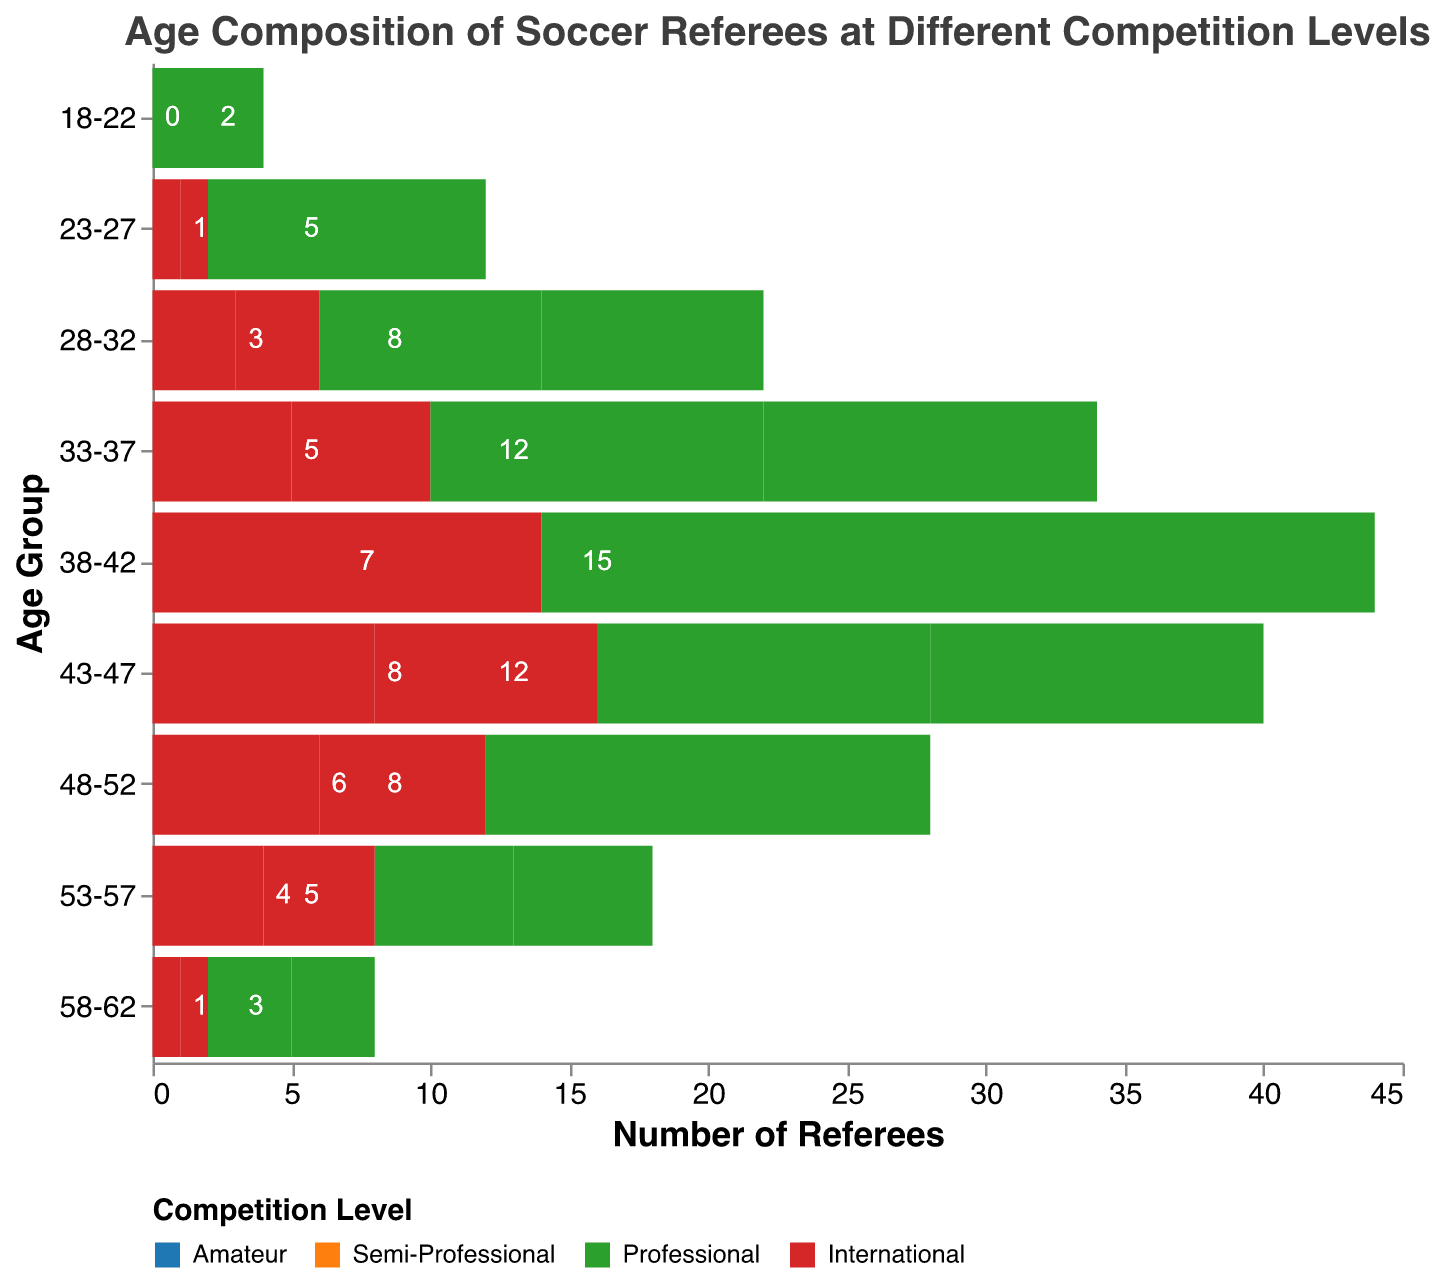What is the title of the figure? The title is at the top of the figure and directly states what the chart represents.
Answer: Age Composition of Soccer Referees at Different Competition Levels Which age group has the highest number of Amateur referees? Look at the left side of the pyramid and identify the age group with the longest bar representing Amateur referees.
Answer: 28-32 How many International referees are there in the 38-42 age group? Locate the 38-42 age group on the right side of the pyramid and check the value for International referees.
Answer: 7 What is the total number of referees in the 33-37 age group? Sum the values for all competition levels in the 33-37 age group: Amateur (17) + Semi-Professional (18) + Professional (12) + International (5).
Answer: 52 Which competition level has the smallest representation in the 18-22 age group? Compare the values for all competition levels in the 18-22 age group and identify the smallest value.
Answer: International How many more Professional referees are there compared to International referees in the 28-32 age group? Subtract the number of International referees (3) from the number of Professional referees (8) in the 28-32 age group.
Answer: 5 In which age group do Semi-Professional referees outnumber Amateur referees by the largest margin? Calculate the differences between Semi-Professional and Amateur referees for each age group and identify the largest positive difference.
Answer: 33-37 What is the combined total number of Professional and International referees in the 23-27 age group? Add the number of Professional referees (5) and International referees (1) in the 23-27 age group.
Answer: 6 Is the number of referees in the 48-52 age group increasing or decreasing across different competition levels? Observe the trend in the number of referees across competition levels: Amateur (5), Semi-Professional (7), Professional (8), International (6).
Answer: Increasing then decreasing 